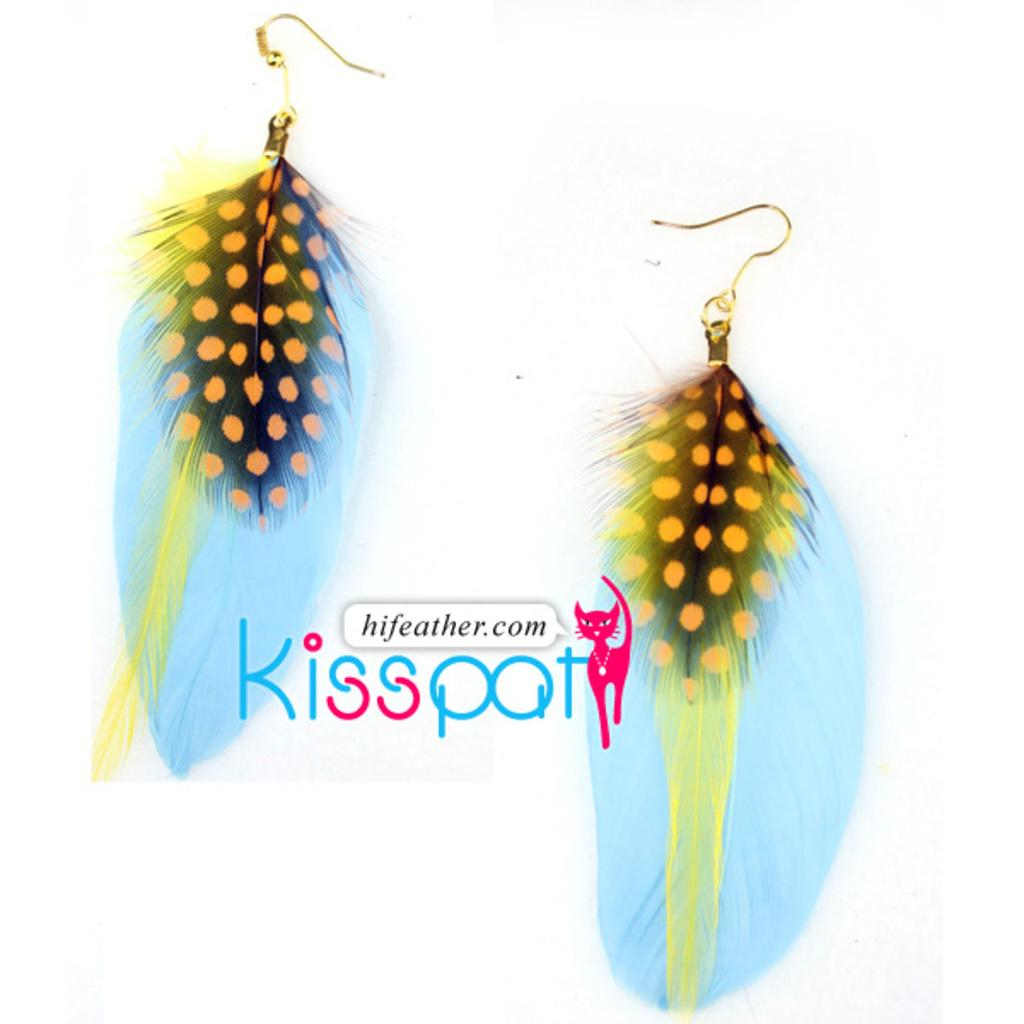What type of accessory is present in the image? There are earrings in the image. What else can be seen in the image besides the earrings? There is text in the image. How much salt is visible in the image? There is no salt present in the image. What type of shelter is shown in the image? There is no tent or shelter present in the image. 